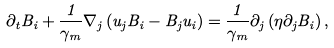<formula> <loc_0><loc_0><loc_500><loc_500>\partial _ { t } B _ { i } + \frac { 1 } { \gamma _ { m } } \nabla _ { j } \left ( u _ { j } B _ { i } - B _ { j } u _ { i } \right ) = \frac { 1 } { \gamma _ { m } } \partial _ { j } \left ( \eta \partial _ { j } B _ { i } \right ) ,</formula> 